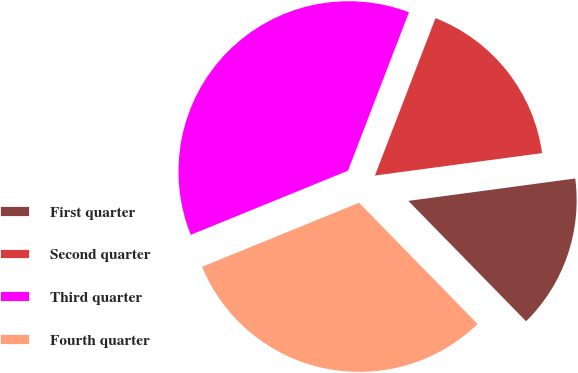<chart> <loc_0><loc_0><loc_500><loc_500><pie_chart><fcel>First quarter<fcel>Second quarter<fcel>Third quarter<fcel>Fourth quarter<nl><fcel>14.8%<fcel>17.03%<fcel>37.01%<fcel>31.16%<nl></chart> 